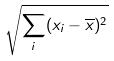<formula> <loc_0><loc_0><loc_500><loc_500>\sqrt { \sum _ { i } ( x _ { i } - \overline { x } ) ^ { 2 } }</formula> 